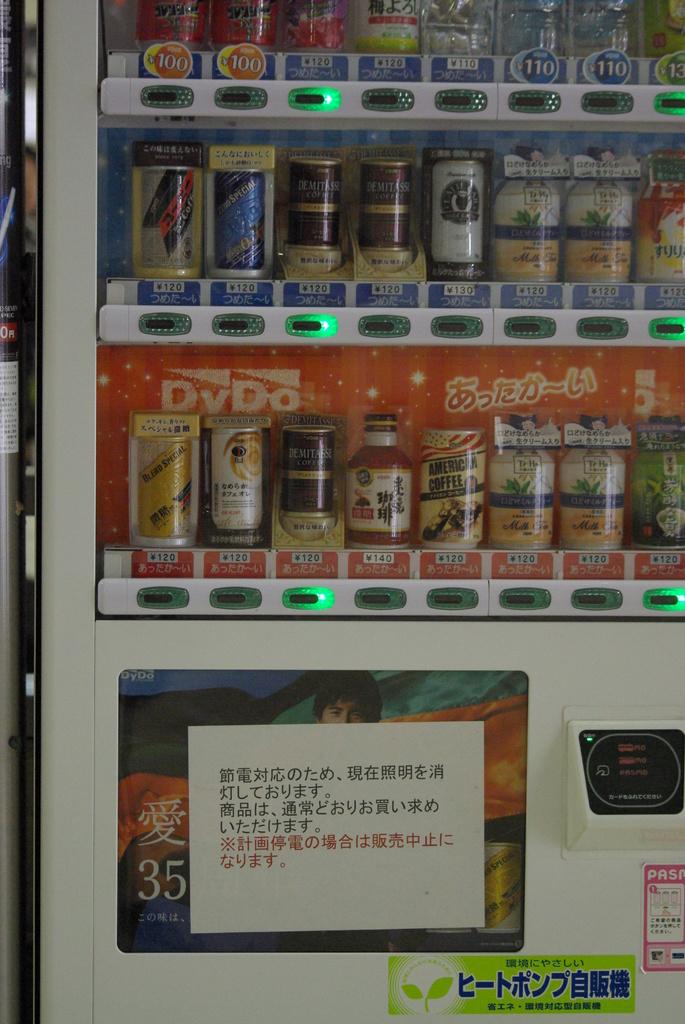How much are the first two drinks on the top left?
Keep it short and to the point. 100. 